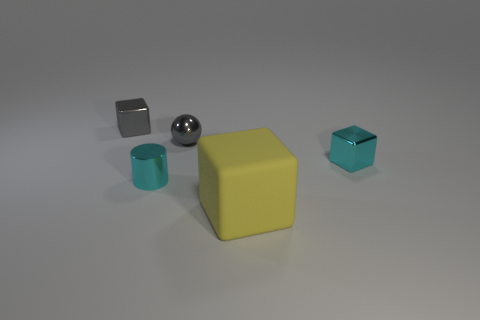Subtract all matte blocks. How many blocks are left? 2 Subtract 1 blocks. How many blocks are left? 2 Add 1 gray metal spheres. How many objects exist? 6 Subtract all cylinders. How many objects are left? 4 Subtract all gray blocks. How many blocks are left? 2 Add 2 tiny metallic objects. How many tiny metallic objects exist? 6 Subtract 0 green balls. How many objects are left? 5 Subtract all purple cylinders. Subtract all gray blocks. How many cylinders are left? 1 Subtract all red cylinders. How many yellow cubes are left? 1 Subtract all cyan cylinders. Subtract all large gray blocks. How many objects are left? 4 